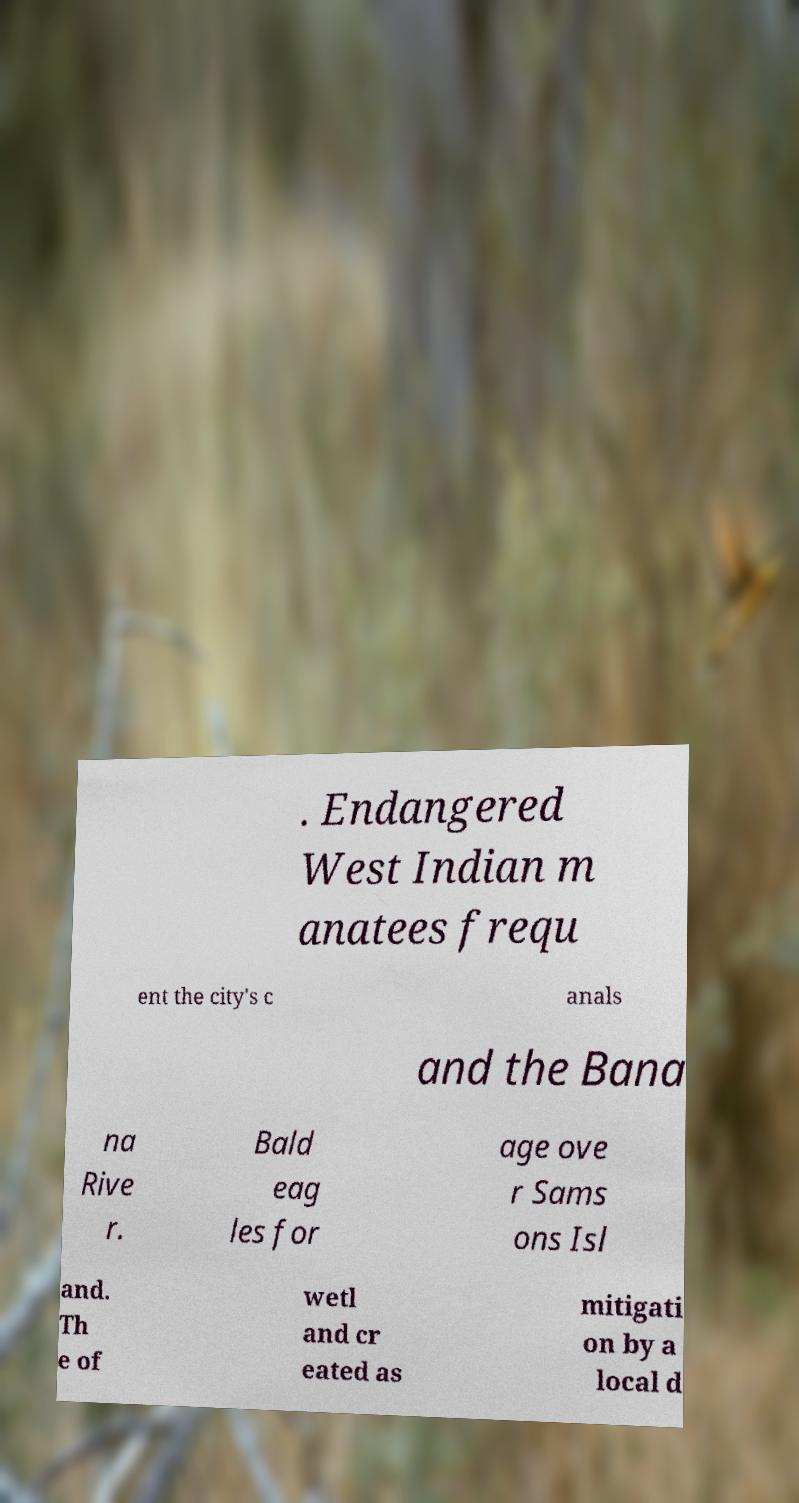There's text embedded in this image that I need extracted. Can you transcribe it verbatim? . Endangered West Indian m anatees frequ ent the city's c anals and the Bana na Rive r. Bald eag les for age ove r Sams ons Isl and. Th e of wetl and cr eated as mitigati on by a local d 